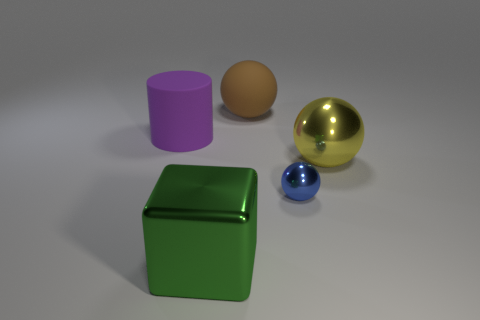Do the tiny blue object and the brown matte object have the same shape?
Your answer should be compact. Yes. How many other objects are there of the same shape as the tiny shiny object?
Offer a very short reply. 2. There is a shiny sphere that is the same size as the metallic block; what color is it?
Provide a succinct answer. Yellow. Is the number of matte spheres that are on the left side of the green shiny thing the same as the number of small red rubber balls?
Provide a succinct answer. Yes. There is a thing that is behind the tiny thing and to the right of the brown object; what is its shape?
Offer a very short reply. Sphere. Is the yellow ball the same size as the blue sphere?
Your response must be concise. No. Is there a large green thing made of the same material as the large purple object?
Provide a succinct answer. No. How many things are behind the big purple cylinder and to the right of the rubber ball?
Your response must be concise. 0. What is the sphere that is behind the purple cylinder made of?
Your answer should be compact. Rubber. There is a blue object that is the same material as the big yellow ball; what size is it?
Make the answer very short. Small. 